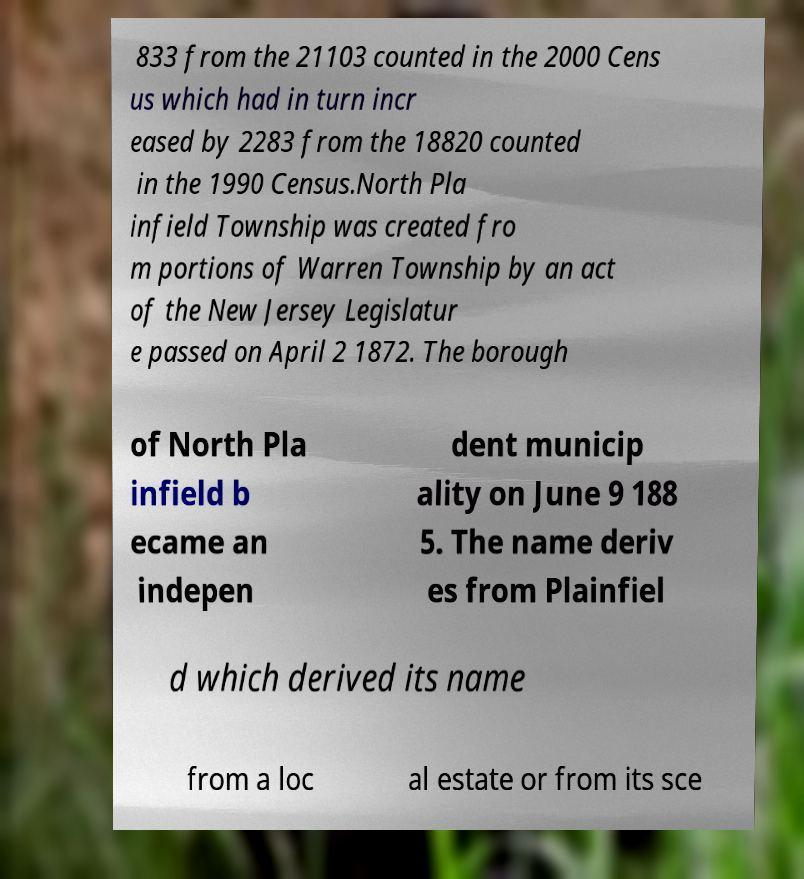For documentation purposes, I need the text within this image transcribed. Could you provide that? 833 from the 21103 counted in the 2000 Cens us which had in turn incr eased by 2283 from the 18820 counted in the 1990 Census.North Pla infield Township was created fro m portions of Warren Township by an act of the New Jersey Legislatur e passed on April 2 1872. The borough of North Pla infield b ecame an indepen dent municip ality on June 9 188 5. The name deriv es from Plainfiel d which derived its name from a loc al estate or from its sce 